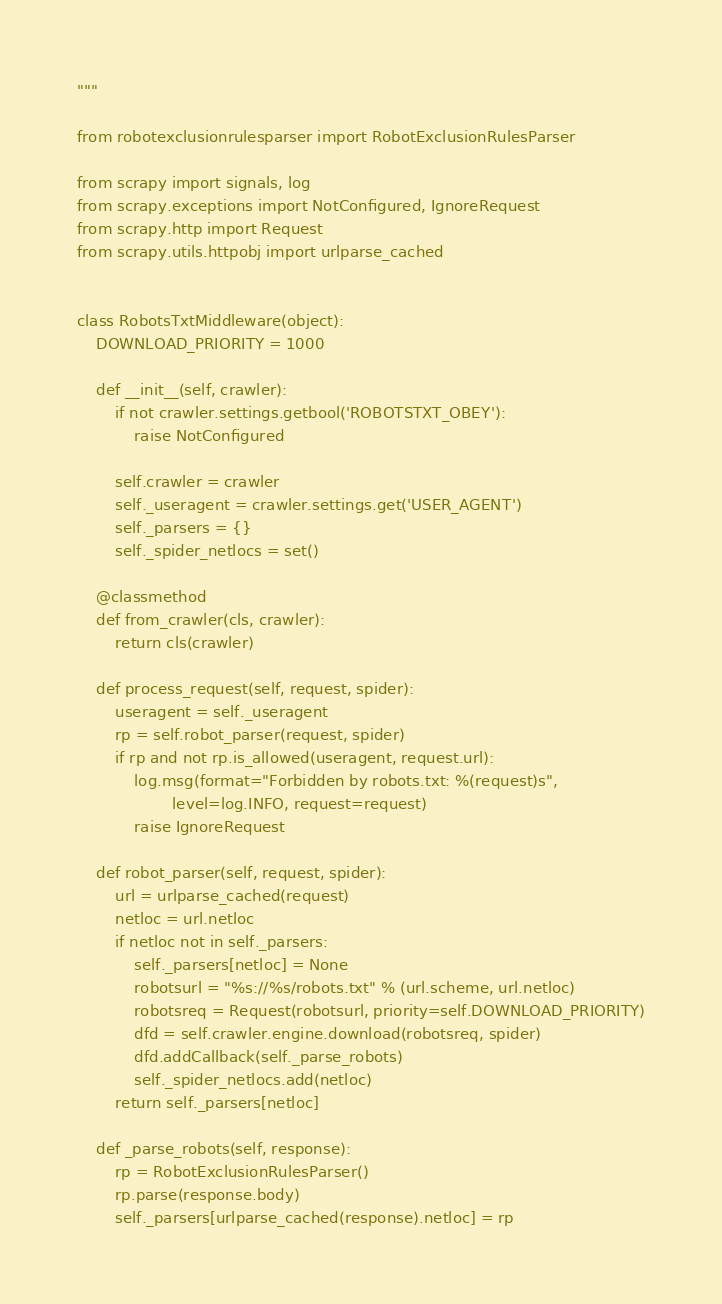<code> <loc_0><loc_0><loc_500><loc_500><_Python_>
"""

from robotexclusionrulesparser import RobotExclusionRulesParser

from scrapy import signals, log
from scrapy.exceptions import NotConfigured, IgnoreRequest
from scrapy.http import Request
from scrapy.utils.httpobj import urlparse_cached


class RobotsTxtMiddleware(object):
    DOWNLOAD_PRIORITY = 1000

    def __init__(self, crawler):
        if not crawler.settings.getbool('ROBOTSTXT_OBEY'):
            raise NotConfigured

        self.crawler = crawler
        self._useragent = crawler.settings.get('USER_AGENT')
        self._parsers = {}
        self._spider_netlocs = set()

    @classmethod
    def from_crawler(cls, crawler):
        return cls(crawler)

    def process_request(self, request, spider):
        useragent = self._useragent
        rp = self.robot_parser(request, spider)
        if rp and not rp.is_allowed(useragent, request.url):
            log.msg(format="Forbidden by robots.txt: %(request)s",
                    level=log.INFO, request=request)
            raise IgnoreRequest

    def robot_parser(self, request, spider):
        url = urlparse_cached(request)
        netloc = url.netloc
        if netloc not in self._parsers:
            self._parsers[netloc] = None
            robotsurl = "%s://%s/robots.txt" % (url.scheme, url.netloc)
            robotsreq = Request(robotsurl, priority=self.DOWNLOAD_PRIORITY)
            dfd = self.crawler.engine.download(robotsreq, spider)
            dfd.addCallback(self._parse_robots)
            self._spider_netlocs.add(netloc)
        return self._parsers[netloc]

    def _parse_robots(self, response):
        rp = RobotExclusionRulesParser()
        rp.parse(response.body)
        self._parsers[urlparse_cached(response).netloc] = rp
</code> 